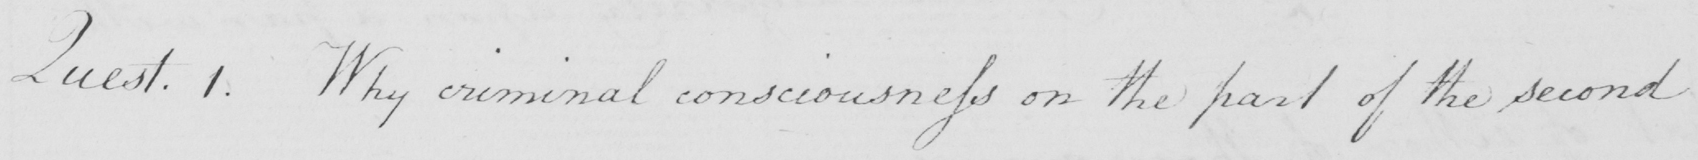What does this handwritten line say? Quest . 1 . Why criminal consciousness on the part of the second 